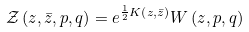Convert formula to latex. <formula><loc_0><loc_0><loc_500><loc_500>\mathcal { Z } \left ( z , { \bar { z } } , p , q \right ) = e ^ { \frac { 1 } { 2 } K \left ( z , { \bar { z } } \right ) } W \left ( z , p , q \right ) \,</formula> 